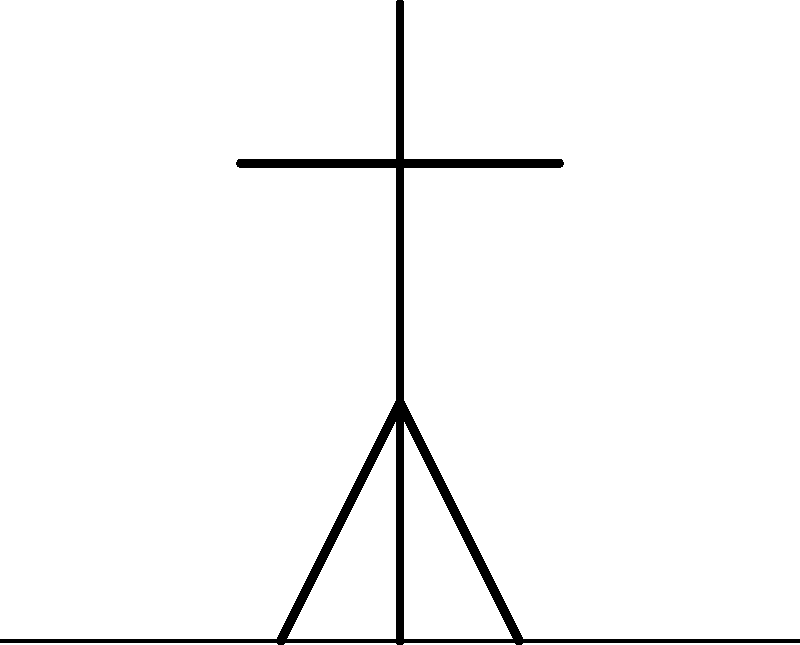In the diagram above, a person is standing still on level ground. Two forces are represented by arrows: gravity (blue) and ground reaction force (red). Which of the following statements is correct regarding these forces?

A) The gravity force is greater than the ground reaction force
B) The ground reaction force is greater than the gravity force
C) The two forces are equal in magnitude but opposite in direction
D) The two forces are equal in both magnitude and direction Let's approach this step-by-step:

1) First, we need to understand what each force represents:
   - Gravity is the force exerted by the Earth on the person, pulling them downwards.
   - Ground reaction force is the force exerted by the ground on the person, pushing upwards.

2) Now, let's consider the person's state:
   - The person is standing still, which means they are not moving up or down.
   - In physics terms, this means the person is in equilibrium.

3) For an object to be in equilibrium, the net force acting on it must be zero:
   - This means that all forces acting on the object must balance out.

4) In this case, we have two forces acting vertically on the person:
   - Gravity acting downwards
   - Ground reaction force acting upwards

5) For the person to remain stationary:
   - These two forces must be equal in magnitude (strength)
   - They must be opposite in direction

6) If the forces were not equal and opposite:
   - The person would start moving either up or down, which is not the case here.

Therefore, the correct statement is that the two forces are equal in magnitude but opposite in direction.
Answer: The two forces are equal in magnitude but opposite in direction. 